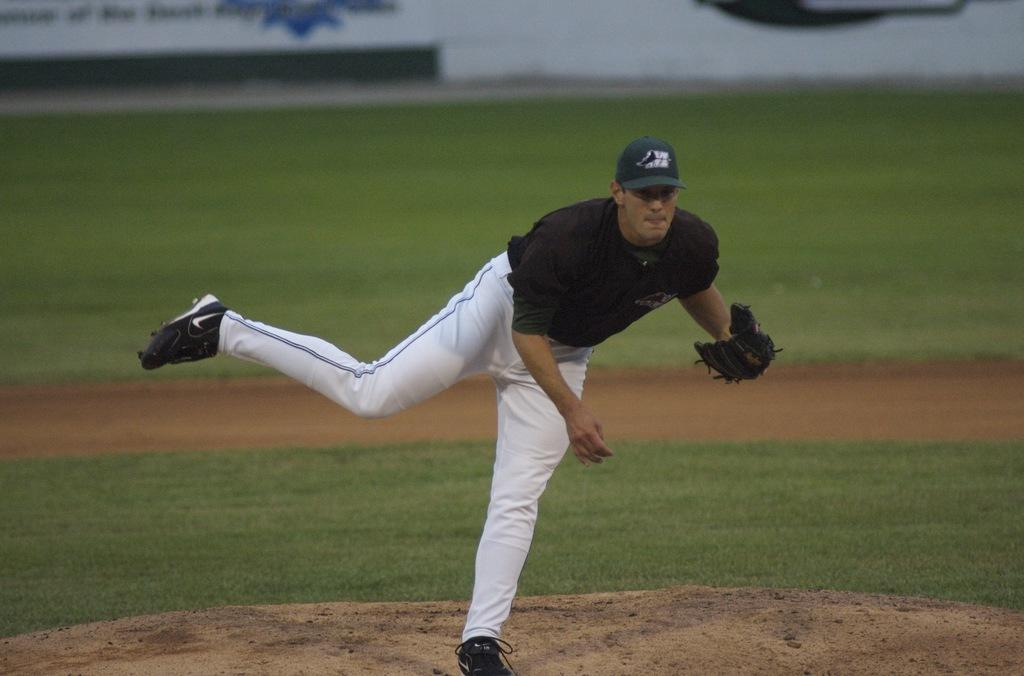Who is present in the image? There is a man in the image. What is the man wearing on his head? The man is wearing a cap. What other clothing items is the man wearing? The man is wearing gloves and shoes. What is the man standing on in the image? The man is standing on the ground. What can be seen in the background of the image? There is grass and a board in the background of the image. What is the dog's tendency in the image? There is no dog present in the image, so it is not possible to determine any tendencies. 